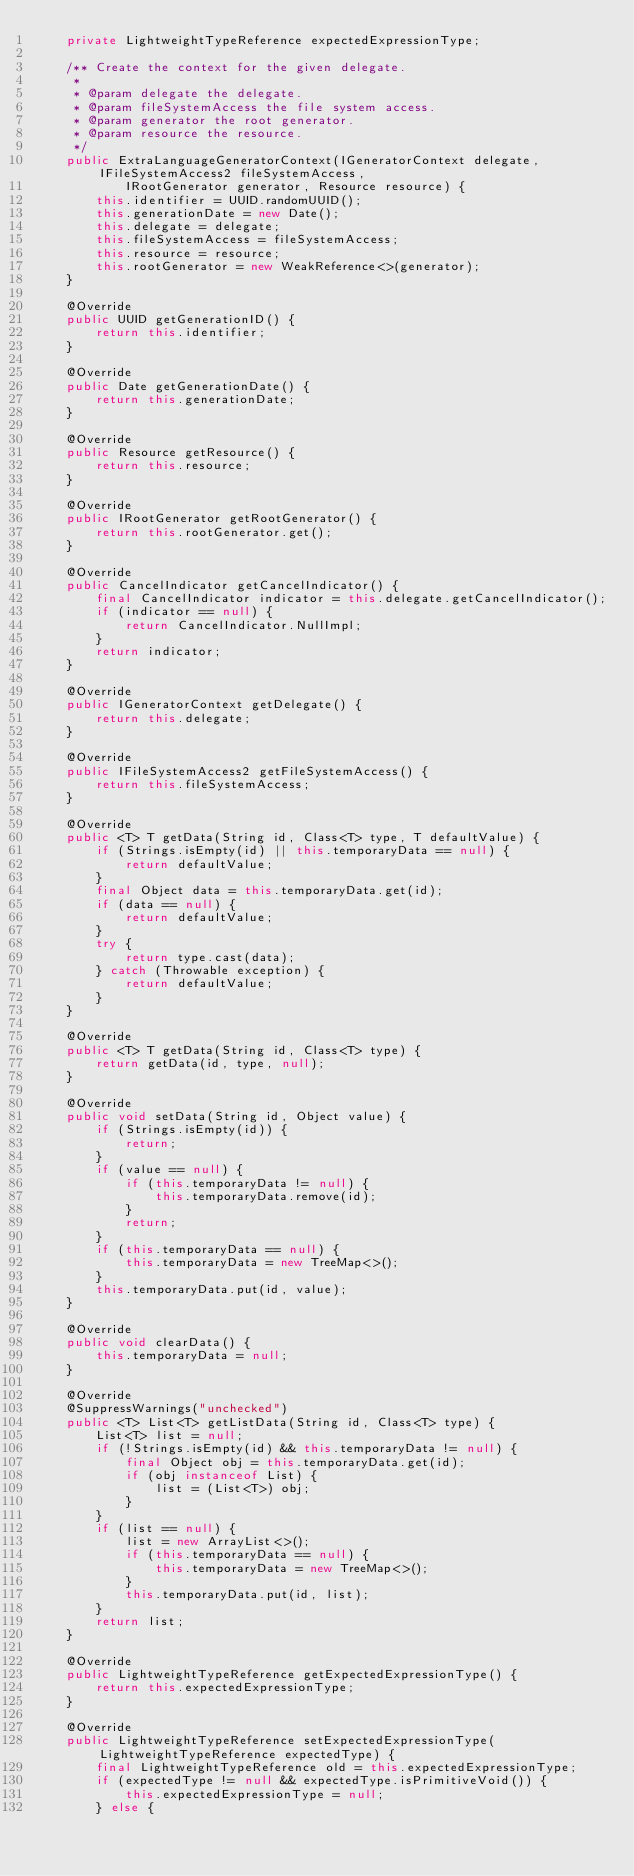<code> <loc_0><loc_0><loc_500><loc_500><_Java_>	private LightweightTypeReference expectedExpressionType;

	/** Create the context for the given delegate.
	 *
	 * @param delegate the delegate.
	 * @param fileSystemAccess the file system access.
	 * @param generator the root generator.
	 * @param resource the resource.
	 */
	public ExtraLanguageGeneratorContext(IGeneratorContext delegate, IFileSystemAccess2 fileSystemAccess,
			IRootGenerator generator, Resource resource) {
		this.identifier = UUID.randomUUID();
		this.generationDate = new Date();
		this.delegate = delegate;
		this.fileSystemAccess = fileSystemAccess;
		this.resource = resource;
		this.rootGenerator = new WeakReference<>(generator);
	}

	@Override
	public UUID getGenerationID() {
		return this.identifier;
	}

	@Override
	public Date getGenerationDate() {
		return this.generationDate;
	}

	@Override
	public Resource getResource() {
		return this.resource;
	}

	@Override
	public IRootGenerator getRootGenerator() {
		return this.rootGenerator.get();
	}

	@Override
	public CancelIndicator getCancelIndicator() {
		final CancelIndicator indicator = this.delegate.getCancelIndicator();
		if (indicator == null) {
			return CancelIndicator.NullImpl;
		}
		return indicator;
	}

	@Override
	public IGeneratorContext getDelegate() {
		return this.delegate;
	}

	@Override
	public IFileSystemAccess2 getFileSystemAccess() {
		return this.fileSystemAccess;
	}

	@Override
	public <T> T getData(String id, Class<T> type, T defaultValue) {
		if (Strings.isEmpty(id) || this.temporaryData == null) {
			return defaultValue;
		}
		final Object data = this.temporaryData.get(id);
		if (data == null) {
			return defaultValue;
		}
		try {
			return type.cast(data);
		} catch (Throwable exception) {
			return defaultValue;
		}
	}

	@Override
	public <T> T getData(String id, Class<T> type) {
		return getData(id, type, null);
	}

	@Override
	public void setData(String id, Object value) {
		if (Strings.isEmpty(id)) {
			return;
		}
		if (value == null) {
			if (this.temporaryData != null) {
				this.temporaryData.remove(id);
			}
			return;
		}
		if (this.temporaryData == null) {
			this.temporaryData = new TreeMap<>();
		}
		this.temporaryData.put(id, value);
	}

	@Override
	public void clearData() {
		this.temporaryData = null;
	}

	@Override
	@SuppressWarnings("unchecked")
	public <T> List<T> getListData(String id, Class<T> type) {
		List<T> list = null;
		if (!Strings.isEmpty(id) && this.temporaryData != null) {
			final Object obj = this.temporaryData.get(id);
			if (obj instanceof List) {
				list = (List<T>) obj;
			}
		}
		if (list == null) {
			list = new ArrayList<>();
			if (this.temporaryData == null) {
				this.temporaryData = new TreeMap<>();
			}
			this.temporaryData.put(id, list);
		}
		return list;
	}

	@Override
	public LightweightTypeReference getExpectedExpressionType() {
		return this.expectedExpressionType;
	}

	@Override
	public LightweightTypeReference setExpectedExpressionType(LightweightTypeReference expectedType) {
		final LightweightTypeReference old = this.expectedExpressionType;
		if (expectedType != null && expectedType.isPrimitiveVoid()) {
			this.expectedExpressionType = null;
		} else {</code> 